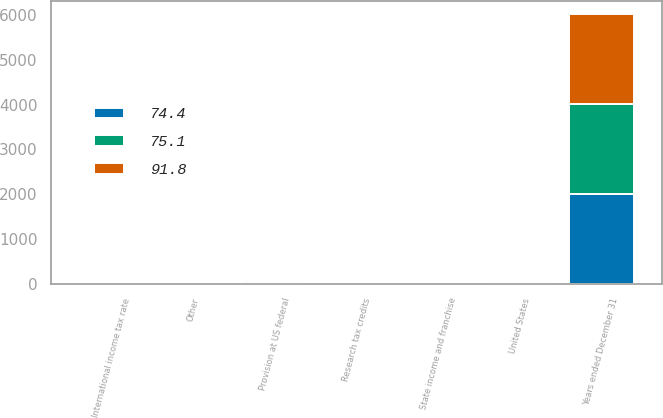<chart> <loc_0><loc_0><loc_500><loc_500><stacked_bar_chart><ecel><fcel>Years ended December 31<fcel>Provision at US federal<fcel>State income and franchise<fcel>International income tax rate<fcel>Research tax credits<fcel>Other<fcel>United States<nl><fcel>91.8<fcel>2010<fcel>35<fcel>1.6<fcel>13.4<fcel>0.4<fcel>0.5<fcel>12.4<nl><fcel>75.1<fcel>2009<fcel>35<fcel>2.9<fcel>6.2<fcel>0.7<fcel>2.7<fcel>48.9<nl><fcel>74.4<fcel>2008<fcel>35<fcel>2.9<fcel>3.8<fcel>0.5<fcel>3.5<fcel>35.6<nl></chart> 